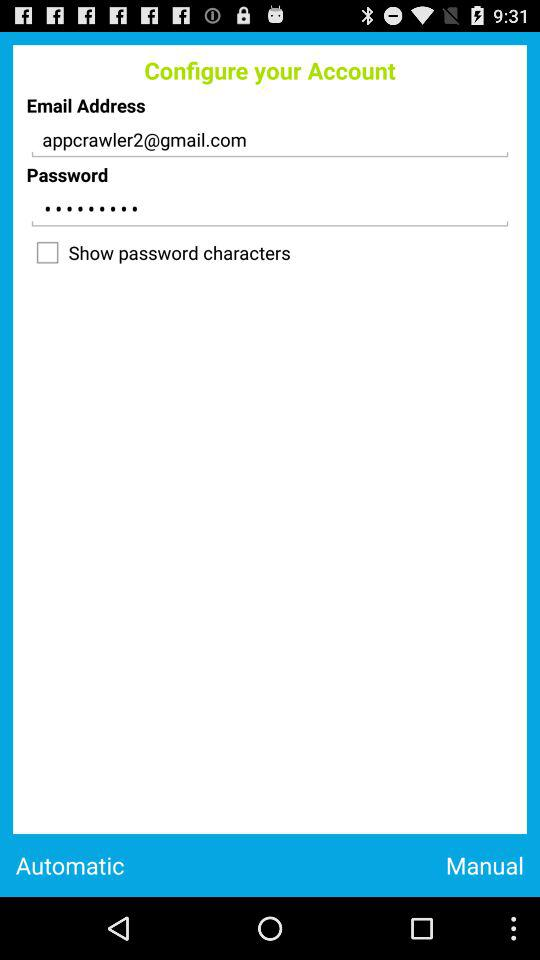What is the email address? The email address is appcrawler2@gmail.com. 